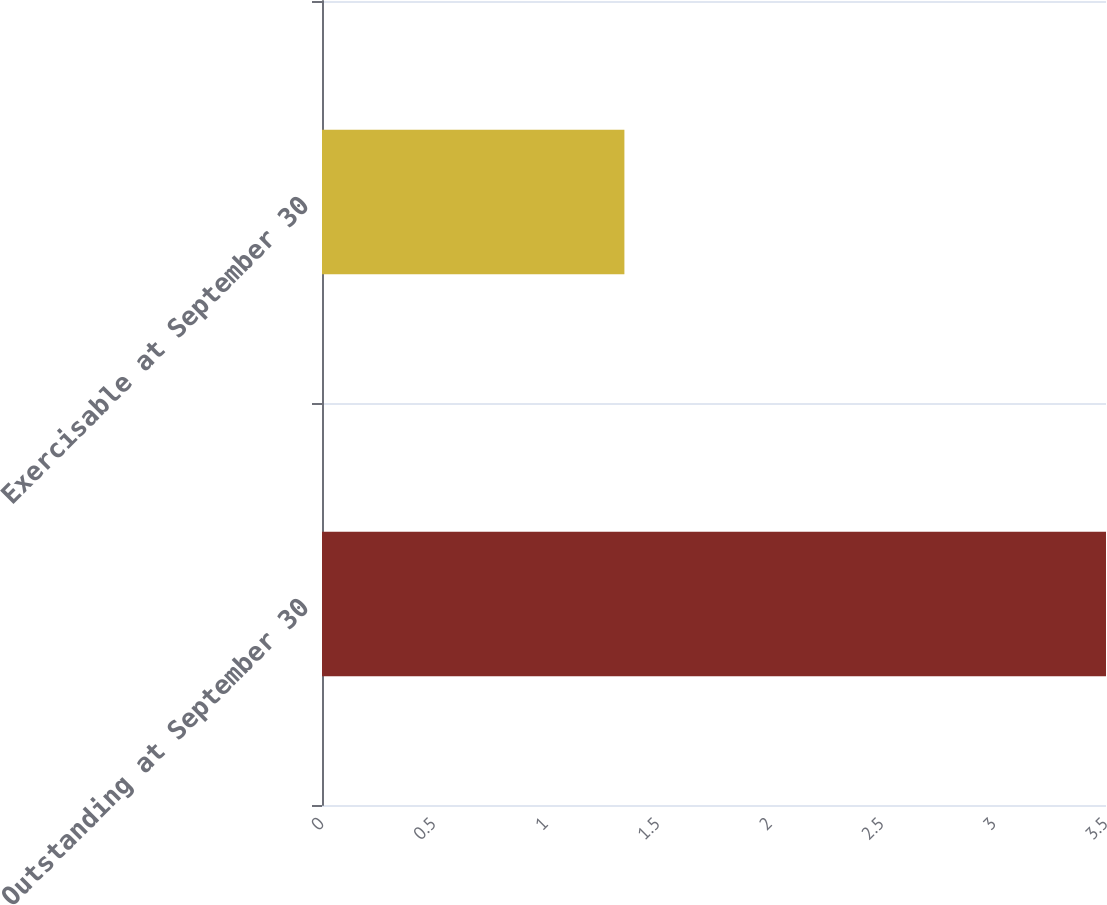<chart> <loc_0><loc_0><loc_500><loc_500><bar_chart><fcel>Outstanding at September 30<fcel>Exercisable at September 30<nl><fcel>3.5<fcel>1.35<nl></chart> 